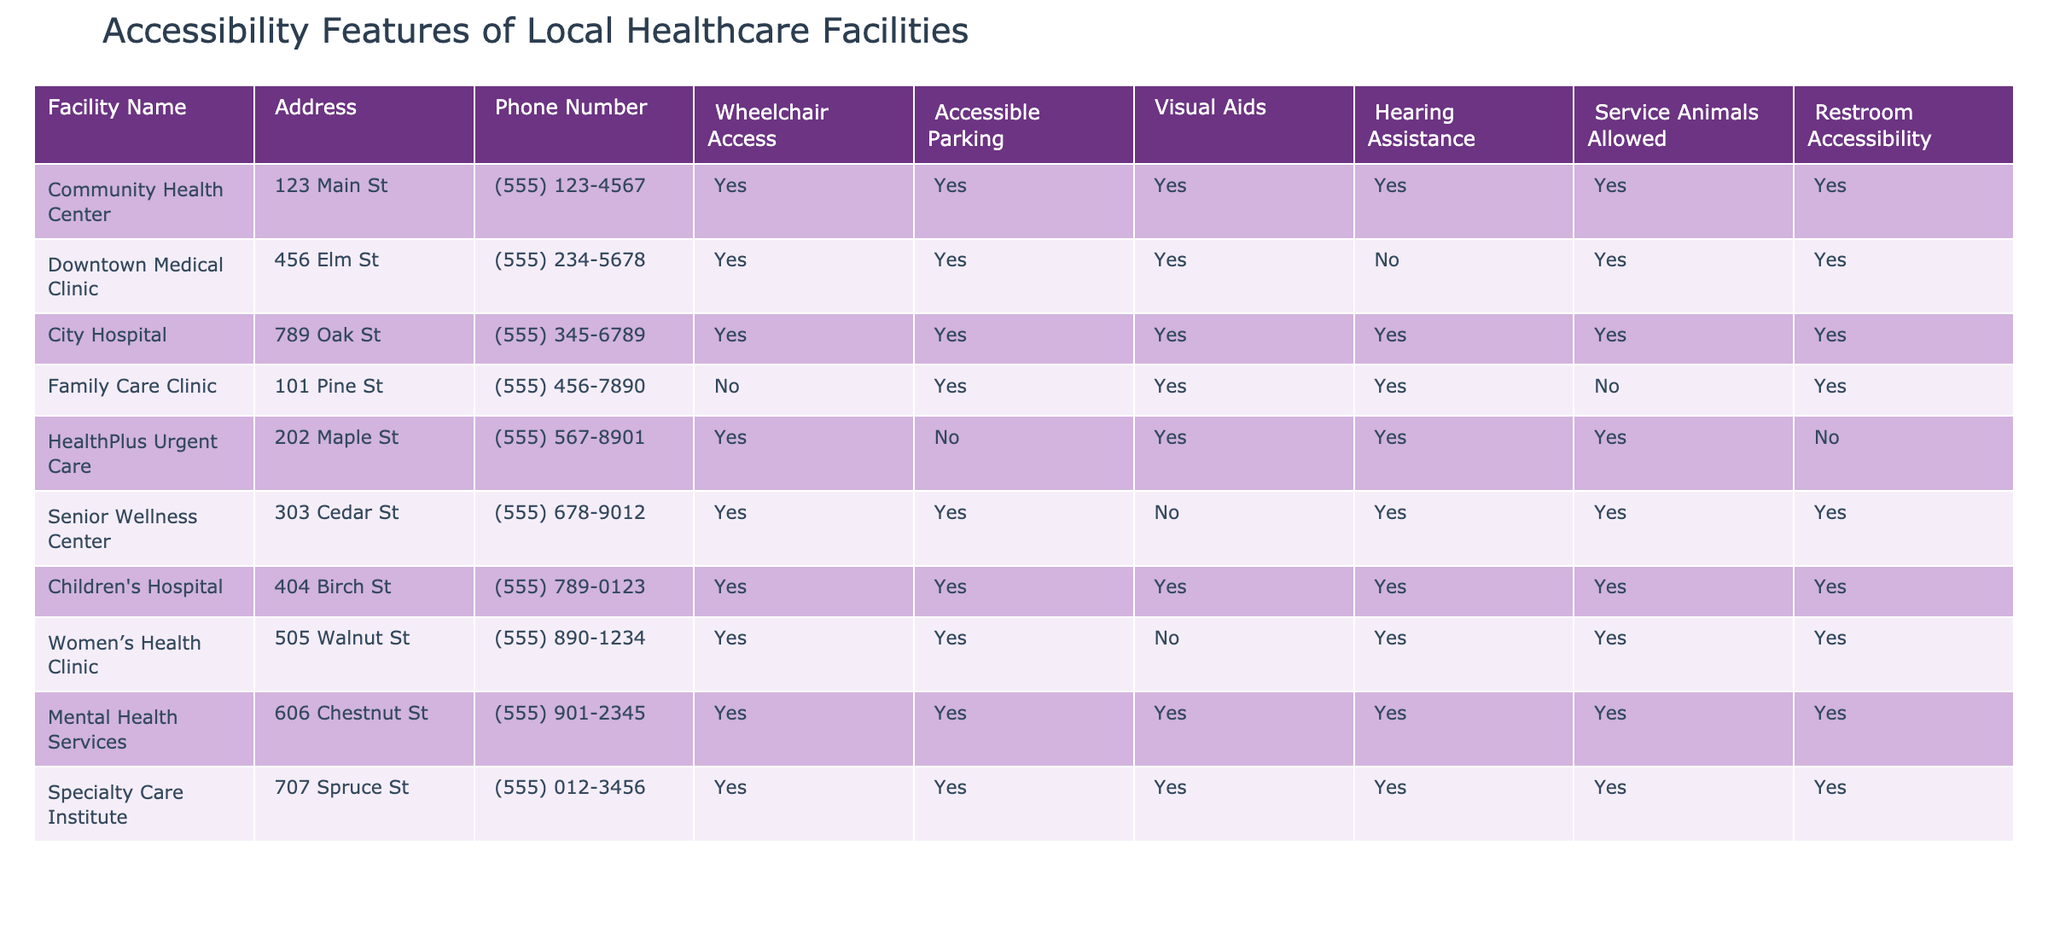What facilities have wheelchair access? To find the facilities with wheelchair access, I look for "Yes" in the Wheelchair Access column. I identify Community Health Center, Downtown Medical Clinic, City Hospital, HealthPlus Urgent Care, Senior Wellness Center, Children's Hospital, Women’s Health Clinic, Mental Health Services, and Specialty Care Institute as those with wheelchair access.
Answer: Community Health Center, Downtown Medical Clinic, City Hospital, HealthPlus Urgent Care, Senior Wellness Center, Children's Hospital, Women’s Health Clinic, Mental Health Services, Specialty Care Institute Are service animals allowed at the Downtown Medical Clinic? I check the Service Animals Allowed column for the Downtown Medical Clinic row. The value is "Yes," indicating that service animals are permitted.
Answer: Yes Which facility does not have restroom accessibility? I scan the Restroom Accessibility column for entries marked "No." The Family Care Clinic and HealthPlus Urgent Care are the only facilities with "No" in this column, meaning they lack restroom accessibility.
Answer: Family Care Clinic, HealthPlus Urgent Care What percentage of facilities provide visual aids for patients? To find the percentage providing visual aids, I count the total number of facilities (10) and those listed "Yes" in the Visual Aids column (8). The formula for the percentage is (8/10) * 100, which equals 80%.
Answer: 80% Is hearing assistance available at the Children’s Hospital? I check the Hearing Assistance column for the Children's Hospital. The value is "Yes," which shows that hearing assistance is available at this facility.
Answer: Yes How many facilities have both wheelchair access and accessible parking? I need to look for facilities that have "Yes" in both the Wheelchair Access and Accessible Parking columns. Counting those, I find Community Health Center, Downtown Medical Clinic, City Hospital, and Children’s Hospital, resulting in a total of 4 facilities.
Answer: 4 Which facility offers hearing assistance but does not allow service animals? I look at the rows where Hearing Assistance is "Yes" but Service Animals Allowed is "No." The Family Care Clinic meets this criterion.
Answer: Family Care Clinic What is the most common accessibility feature among the listed facilities? I analyze each accessibility feature and their availability across the facilities. For wheelchair access, 9 facilities provide it. For accessible parking, 8 facilities provide it. Visual aids are present in 8 facilities, hearing assistance is available in 7 facilities, and restroom accessibility is provided in 7 facilities. Thus, the most common feature is wheelchair access.
Answer: Wheelchair access 